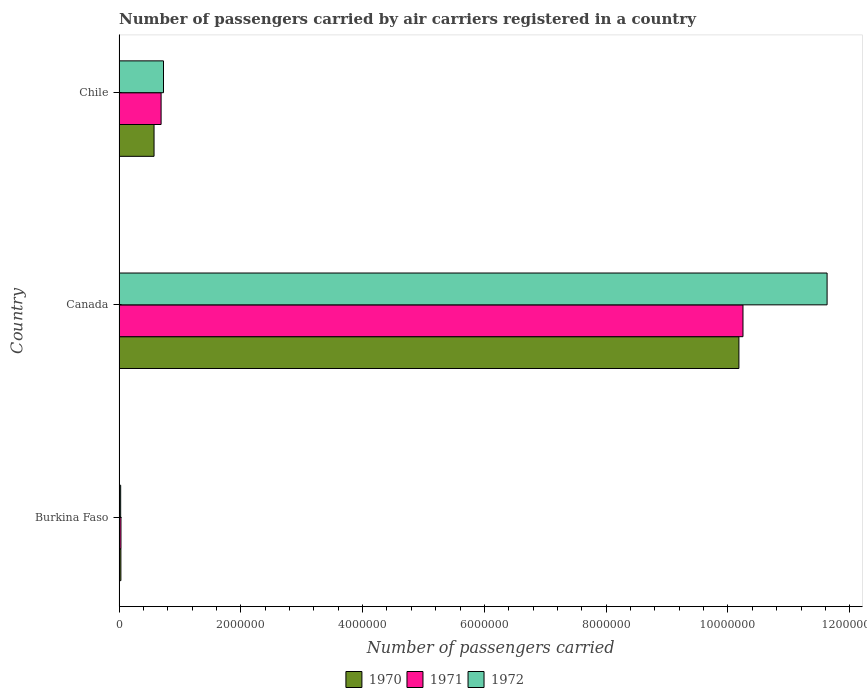How many different coloured bars are there?
Your response must be concise. 3. How many groups of bars are there?
Provide a short and direct response. 3. Are the number of bars per tick equal to the number of legend labels?
Your answer should be compact. Yes. How many bars are there on the 2nd tick from the top?
Provide a succinct answer. 3. What is the label of the 3rd group of bars from the top?
Keep it short and to the point. Burkina Faso. In how many cases, is the number of bars for a given country not equal to the number of legend labels?
Offer a very short reply. 0. What is the number of passengers carried by air carriers in 1970 in Burkina Faso?
Keep it short and to the point. 3.01e+04. Across all countries, what is the maximum number of passengers carried by air carriers in 1971?
Offer a very short reply. 1.02e+07. Across all countries, what is the minimum number of passengers carried by air carriers in 1971?
Give a very brief answer. 3.16e+04. In which country was the number of passengers carried by air carriers in 1971 minimum?
Offer a terse response. Burkina Faso. What is the total number of passengers carried by air carriers in 1971 in the graph?
Give a very brief answer. 1.10e+07. What is the difference between the number of passengers carried by air carriers in 1972 in Burkina Faso and that in Canada?
Offer a very short reply. -1.16e+07. What is the difference between the number of passengers carried by air carriers in 1971 in Burkina Faso and the number of passengers carried by air carriers in 1972 in Chile?
Your answer should be compact. -6.98e+05. What is the average number of passengers carried by air carriers in 1971 per country?
Your answer should be very brief. 3.66e+06. What is the difference between the number of passengers carried by air carriers in 1970 and number of passengers carried by air carriers in 1971 in Burkina Faso?
Provide a short and direct response. -1500. What is the ratio of the number of passengers carried by air carriers in 1972 in Burkina Faso to that in Chile?
Ensure brevity in your answer.  0.04. Is the number of passengers carried by air carriers in 1970 in Burkina Faso less than that in Chile?
Provide a succinct answer. Yes. Is the difference between the number of passengers carried by air carriers in 1970 in Burkina Faso and Canada greater than the difference between the number of passengers carried by air carriers in 1971 in Burkina Faso and Canada?
Provide a short and direct response. Yes. What is the difference between the highest and the second highest number of passengers carried by air carriers in 1972?
Your response must be concise. 1.09e+07. What is the difference between the highest and the lowest number of passengers carried by air carriers in 1970?
Keep it short and to the point. 1.02e+07. In how many countries, is the number of passengers carried by air carriers in 1970 greater than the average number of passengers carried by air carriers in 1970 taken over all countries?
Ensure brevity in your answer.  1. What does the 1st bar from the top in Canada represents?
Your response must be concise. 1972. What does the 1st bar from the bottom in Canada represents?
Provide a succinct answer. 1970. Is it the case that in every country, the sum of the number of passengers carried by air carriers in 1970 and number of passengers carried by air carriers in 1972 is greater than the number of passengers carried by air carriers in 1971?
Your response must be concise. Yes. Are all the bars in the graph horizontal?
Give a very brief answer. Yes. What is the difference between two consecutive major ticks on the X-axis?
Provide a succinct answer. 2.00e+06. Are the values on the major ticks of X-axis written in scientific E-notation?
Make the answer very short. No. Does the graph contain any zero values?
Keep it short and to the point. No. Does the graph contain grids?
Ensure brevity in your answer.  No. How many legend labels are there?
Give a very brief answer. 3. How are the legend labels stacked?
Make the answer very short. Horizontal. What is the title of the graph?
Keep it short and to the point. Number of passengers carried by air carriers registered in a country. Does "2003" appear as one of the legend labels in the graph?
Offer a terse response. No. What is the label or title of the X-axis?
Offer a terse response. Number of passengers carried. What is the Number of passengers carried in 1970 in Burkina Faso?
Ensure brevity in your answer.  3.01e+04. What is the Number of passengers carried in 1971 in Burkina Faso?
Ensure brevity in your answer.  3.16e+04. What is the Number of passengers carried of 1972 in Burkina Faso?
Provide a short and direct response. 2.65e+04. What is the Number of passengers carried in 1970 in Canada?
Your answer should be compact. 1.02e+07. What is the Number of passengers carried of 1971 in Canada?
Offer a very short reply. 1.02e+07. What is the Number of passengers carried of 1972 in Canada?
Keep it short and to the point. 1.16e+07. What is the Number of passengers carried of 1970 in Chile?
Your response must be concise. 5.75e+05. What is the Number of passengers carried of 1971 in Chile?
Keep it short and to the point. 6.91e+05. What is the Number of passengers carried in 1972 in Chile?
Provide a succinct answer. 7.30e+05. Across all countries, what is the maximum Number of passengers carried in 1970?
Your answer should be very brief. 1.02e+07. Across all countries, what is the maximum Number of passengers carried of 1971?
Offer a very short reply. 1.02e+07. Across all countries, what is the maximum Number of passengers carried in 1972?
Give a very brief answer. 1.16e+07. Across all countries, what is the minimum Number of passengers carried in 1970?
Your response must be concise. 3.01e+04. Across all countries, what is the minimum Number of passengers carried of 1971?
Your answer should be compact. 3.16e+04. Across all countries, what is the minimum Number of passengers carried of 1972?
Your answer should be compact. 2.65e+04. What is the total Number of passengers carried in 1970 in the graph?
Give a very brief answer. 1.08e+07. What is the total Number of passengers carried in 1971 in the graph?
Your response must be concise. 1.10e+07. What is the total Number of passengers carried in 1972 in the graph?
Provide a short and direct response. 1.24e+07. What is the difference between the Number of passengers carried in 1970 in Burkina Faso and that in Canada?
Provide a short and direct response. -1.02e+07. What is the difference between the Number of passengers carried in 1971 in Burkina Faso and that in Canada?
Provide a short and direct response. -1.02e+07. What is the difference between the Number of passengers carried of 1972 in Burkina Faso and that in Canada?
Your response must be concise. -1.16e+07. What is the difference between the Number of passengers carried in 1970 in Burkina Faso and that in Chile?
Offer a terse response. -5.45e+05. What is the difference between the Number of passengers carried in 1971 in Burkina Faso and that in Chile?
Make the answer very short. -6.59e+05. What is the difference between the Number of passengers carried of 1972 in Burkina Faso and that in Chile?
Ensure brevity in your answer.  -7.04e+05. What is the difference between the Number of passengers carried of 1970 in Canada and that in Chile?
Provide a short and direct response. 9.61e+06. What is the difference between the Number of passengers carried in 1971 in Canada and that in Chile?
Your response must be concise. 9.56e+06. What is the difference between the Number of passengers carried of 1972 in Canada and that in Chile?
Keep it short and to the point. 1.09e+07. What is the difference between the Number of passengers carried of 1970 in Burkina Faso and the Number of passengers carried of 1971 in Canada?
Your answer should be compact. -1.02e+07. What is the difference between the Number of passengers carried of 1970 in Burkina Faso and the Number of passengers carried of 1972 in Canada?
Your response must be concise. -1.16e+07. What is the difference between the Number of passengers carried of 1971 in Burkina Faso and the Number of passengers carried of 1972 in Canada?
Give a very brief answer. -1.16e+07. What is the difference between the Number of passengers carried in 1970 in Burkina Faso and the Number of passengers carried in 1971 in Chile?
Ensure brevity in your answer.  -6.60e+05. What is the difference between the Number of passengers carried in 1970 in Burkina Faso and the Number of passengers carried in 1972 in Chile?
Give a very brief answer. -7.00e+05. What is the difference between the Number of passengers carried of 1971 in Burkina Faso and the Number of passengers carried of 1972 in Chile?
Your response must be concise. -6.98e+05. What is the difference between the Number of passengers carried of 1970 in Canada and the Number of passengers carried of 1971 in Chile?
Your response must be concise. 9.49e+06. What is the difference between the Number of passengers carried of 1970 in Canada and the Number of passengers carried of 1972 in Chile?
Provide a short and direct response. 9.45e+06. What is the difference between the Number of passengers carried in 1971 in Canada and the Number of passengers carried in 1972 in Chile?
Your answer should be compact. 9.52e+06. What is the average Number of passengers carried of 1970 per country?
Offer a terse response. 3.60e+06. What is the average Number of passengers carried in 1971 per country?
Keep it short and to the point. 3.66e+06. What is the average Number of passengers carried in 1972 per country?
Ensure brevity in your answer.  4.13e+06. What is the difference between the Number of passengers carried of 1970 and Number of passengers carried of 1971 in Burkina Faso?
Provide a succinct answer. -1500. What is the difference between the Number of passengers carried of 1970 and Number of passengers carried of 1972 in Burkina Faso?
Keep it short and to the point. 3600. What is the difference between the Number of passengers carried of 1971 and Number of passengers carried of 1972 in Burkina Faso?
Make the answer very short. 5100. What is the difference between the Number of passengers carried of 1970 and Number of passengers carried of 1971 in Canada?
Your answer should be compact. -6.70e+04. What is the difference between the Number of passengers carried in 1970 and Number of passengers carried in 1972 in Canada?
Provide a short and direct response. -1.45e+06. What is the difference between the Number of passengers carried of 1971 and Number of passengers carried of 1972 in Canada?
Offer a very short reply. -1.38e+06. What is the difference between the Number of passengers carried of 1970 and Number of passengers carried of 1971 in Chile?
Keep it short and to the point. -1.16e+05. What is the difference between the Number of passengers carried of 1970 and Number of passengers carried of 1972 in Chile?
Offer a terse response. -1.55e+05. What is the difference between the Number of passengers carried in 1971 and Number of passengers carried in 1972 in Chile?
Keep it short and to the point. -3.94e+04. What is the ratio of the Number of passengers carried in 1970 in Burkina Faso to that in Canada?
Provide a succinct answer. 0. What is the ratio of the Number of passengers carried in 1971 in Burkina Faso to that in Canada?
Your response must be concise. 0. What is the ratio of the Number of passengers carried in 1972 in Burkina Faso to that in Canada?
Your response must be concise. 0. What is the ratio of the Number of passengers carried in 1970 in Burkina Faso to that in Chile?
Keep it short and to the point. 0.05. What is the ratio of the Number of passengers carried in 1971 in Burkina Faso to that in Chile?
Make the answer very short. 0.05. What is the ratio of the Number of passengers carried in 1972 in Burkina Faso to that in Chile?
Provide a short and direct response. 0.04. What is the ratio of the Number of passengers carried of 1970 in Canada to that in Chile?
Provide a short and direct response. 17.71. What is the ratio of the Number of passengers carried in 1971 in Canada to that in Chile?
Provide a short and direct response. 14.84. What is the ratio of the Number of passengers carried in 1972 in Canada to that in Chile?
Offer a terse response. 15.93. What is the difference between the highest and the second highest Number of passengers carried in 1970?
Keep it short and to the point. 9.61e+06. What is the difference between the highest and the second highest Number of passengers carried of 1971?
Offer a very short reply. 9.56e+06. What is the difference between the highest and the second highest Number of passengers carried in 1972?
Ensure brevity in your answer.  1.09e+07. What is the difference between the highest and the lowest Number of passengers carried in 1970?
Provide a short and direct response. 1.02e+07. What is the difference between the highest and the lowest Number of passengers carried in 1971?
Offer a very short reply. 1.02e+07. What is the difference between the highest and the lowest Number of passengers carried of 1972?
Give a very brief answer. 1.16e+07. 